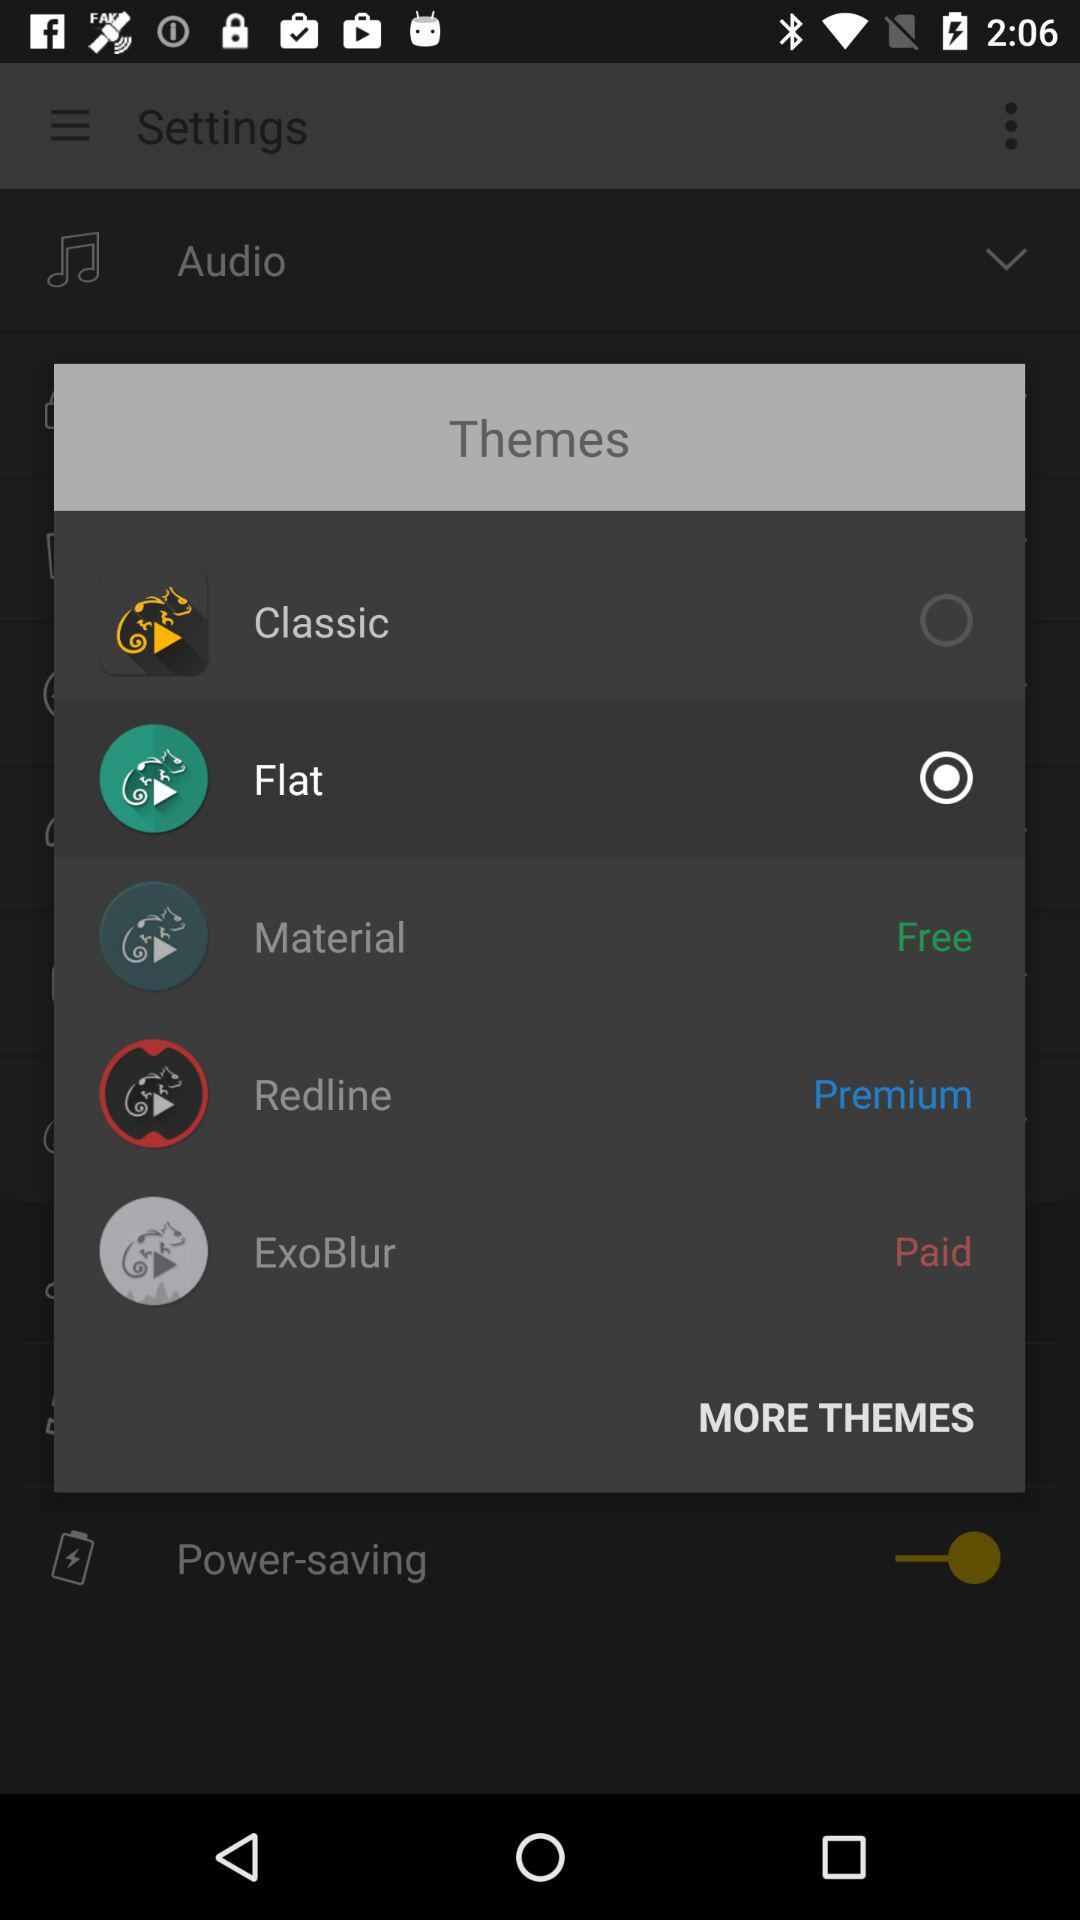What theme is free? The free theme is "Material". 